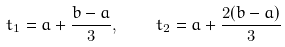<formula> <loc_0><loc_0><loc_500><loc_500>t _ { 1 } = a + \frac { b - a } { 3 } , \quad t _ { 2 } = a + \frac { 2 ( b - a ) } { 3 }</formula> 